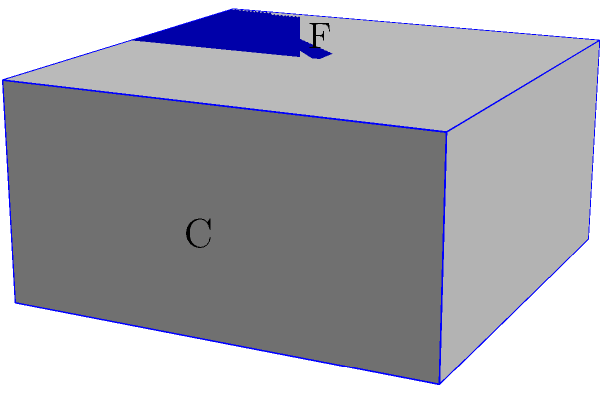As an industrial designer, you're tasked with creating a futuristic packaging design for a new tech product. The package needs to be a cube when folded. Given the unfolded pattern shown in the image, which face will be opposite to face F when the cube is formed? To solve this problem, we need to mentally fold the given pattern into a cube and visualize the relative positions of the faces. Let's follow these steps:

1. Identify the base face: Face A is the base of the cube.

2. Understand the adjacent faces:
   - Face B is the front face
   - Face C is the right face
   - Face D is the back face
   - Face E is the left face

3. Locate face F: Face F is the top face of the cube when folded.

4. Determine the opposite face:
   - In a cube, opposite faces are parallel to each other and do not share any edges.
   - The face opposite to the top face (F) would be the bottom face of the cube.
   - When we fold the pattern, the bottom face of the cube will be face A.

5. Verify:
   - Imagine folding the side faces (B, C, D, E) up from face A.
   - Face F will naturally form the top of the cube.
   - Face A will remain as the bottom of the cube, directly opposite to face F.

Therefore, when the cube is formed, face A will be opposite to face F.
Answer: A 